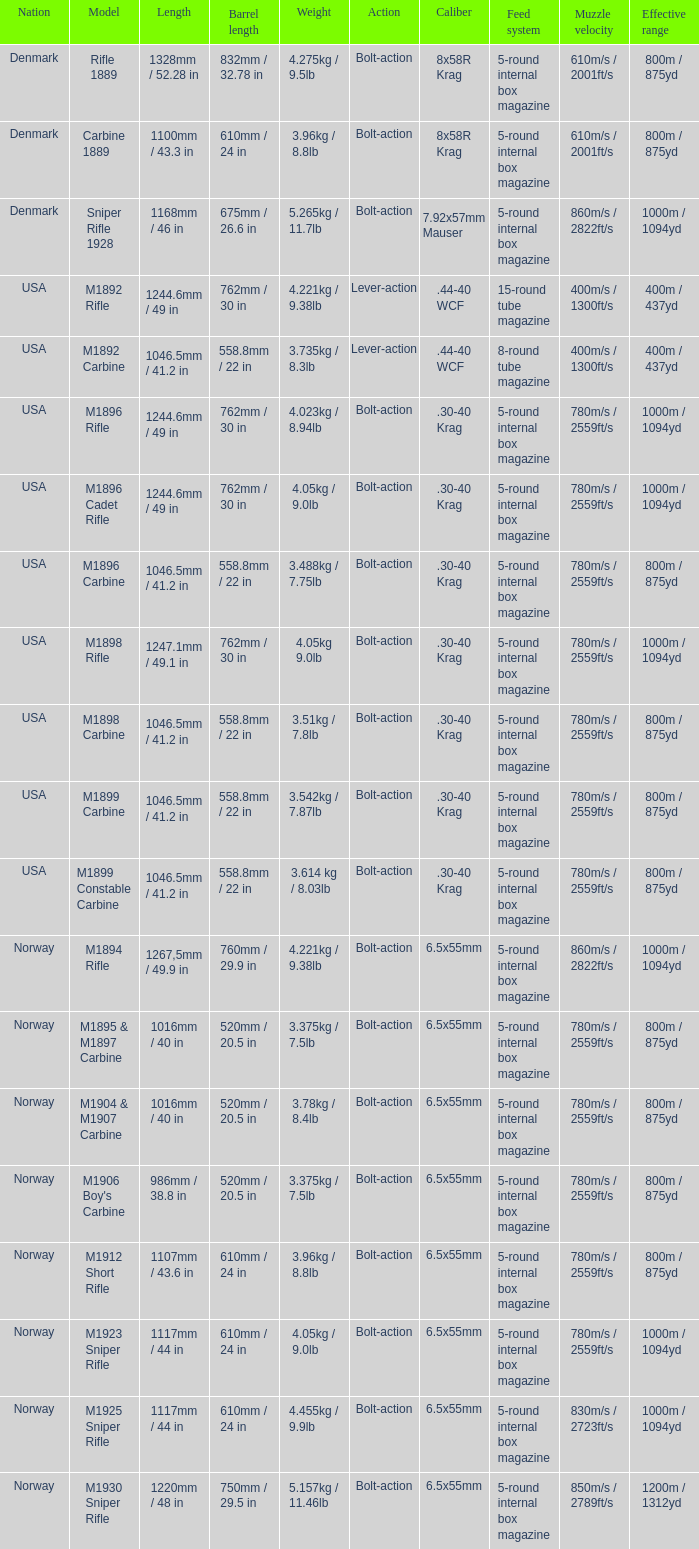What is Weight, when Length is 1168mm / 46 in? 5.265kg / 11.7lb. 